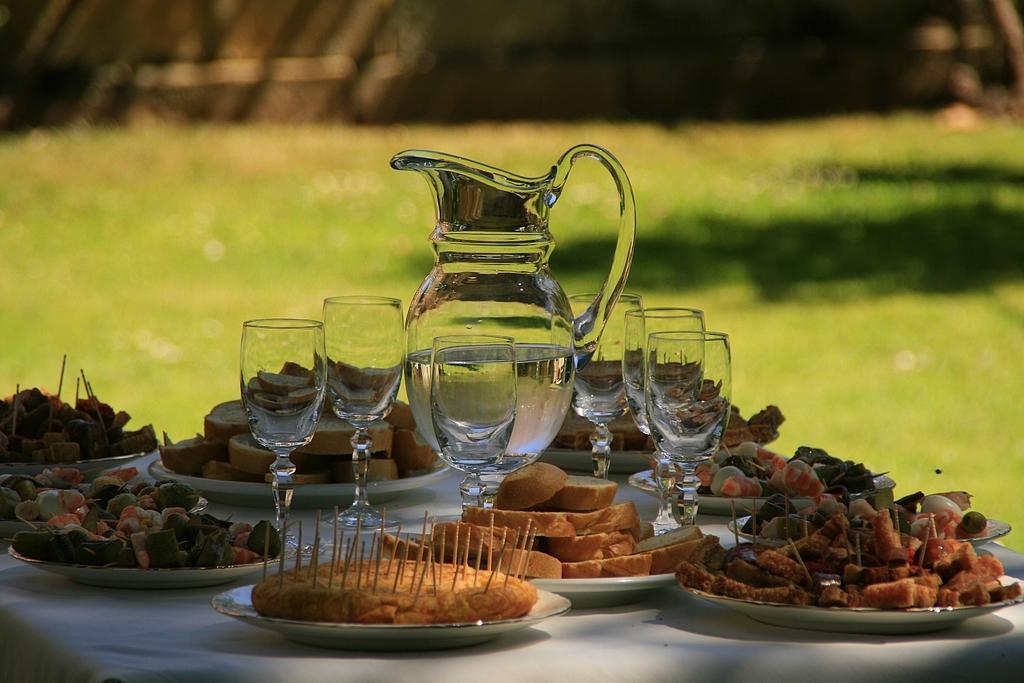Can you describe this image briefly? In this image we can see group of glasses and a jar containing water in it is placed on a table on which group of plates containing several food items, group of toothpicks are placed on it. 